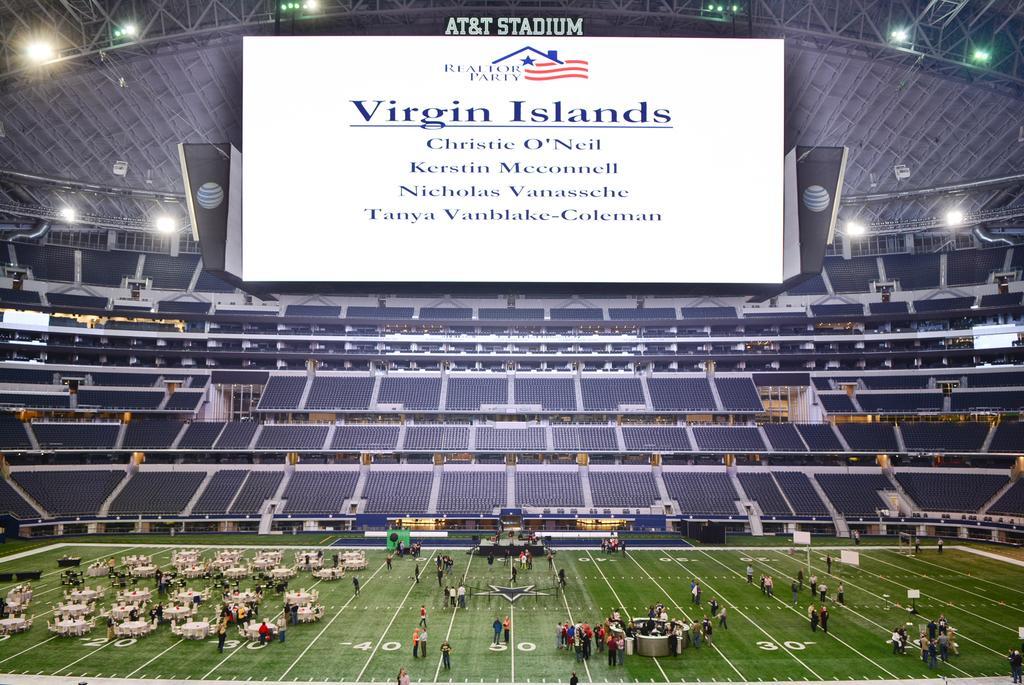Could you give a brief overview of what you see in this image? This picture is taken in a ground, there are some people standing, there are some chairs, at the top there is a white color display, on that there is VIRGIN ISLAND written. 